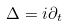<formula> <loc_0><loc_0><loc_500><loc_500>\Delta = i \partial _ { t }</formula> 